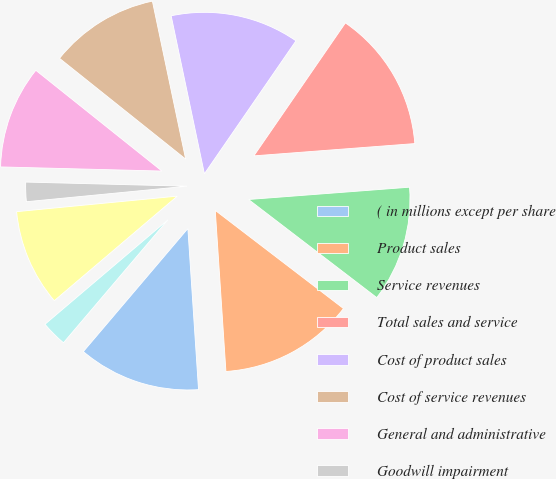<chart> <loc_0><loc_0><loc_500><loc_500><pie_chart><fcel>( in millions except per share<fcel>Product sales<fcel>Service revenues<fcel>Total sales and service<fcel>Cost of product sales<fcel>Cost of service revenues<fcel>General and administrative<fcel>Goodwill impairment<fcel>Operating income (loss)<fcel>Interest expense<nl><fcel>12.26%<fcel>13.55%<fcel>11.61%<fcel>14.19%<fcel>12.9%<fcel>10.97%<fcel>10.32%<fcel>1.94%<fcel>9.68%<fcel>2.58%<nl></chart> 